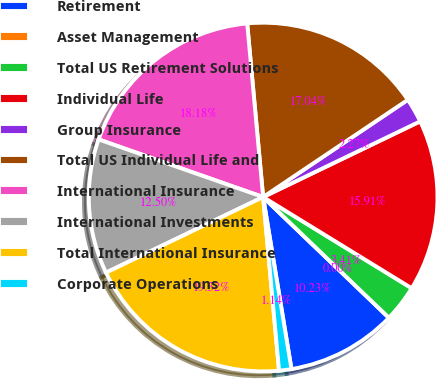Convert chart. <chart><loc_0><loc_0><loc_500><loc_500><pie_chart><fcel>Retirement<fcel>Asset Management<fcel>Total US Retirement Solutions<fcel>Individual Life<fcel>Group Insurance<fcel>Total US Individual Life and<fcel>International Insurance<fcel>International Investments<fcel>Total International Insurance<fcel>Corporate Operations<nl><fcel>10.23%<fcel>0.0%<fcel>3.41%<fcel>15.91%<fcel>2.27%<fcel>17.04%<fcel>18.18%<fcel>12.5%<fcel>19.32%<fcel>1.14%<nl></chart> 